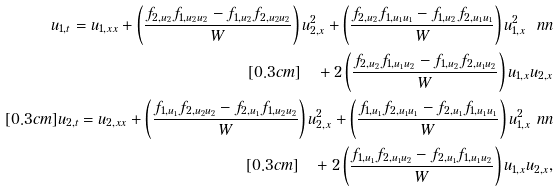Convert formula to latex. <formula><loc_0><loc_0><loc_500><loc_500>u _ { 1 , t } = u _ { 1 , x x } + \left ( \frac { f _ { 2 , u _ { 2 } } f _ { 1 , u _ { 2 } u _ { 2 } } - f _ { 1 , u _ { 2 } } f _ { 2 , u _ { 2 } u _ { 2 } } } { W } \right ) u _ { 2 , x } ^ { 2 } + \left ( \frac { f _ { 2 , u _ { 2 } } f _ { 1 , u _ { 1 } u _ { 1 } } - f _ { 1 , u _ { 2 } } f _ { 2 , u _ { 1 } u _ { 1 } } } { W } \right ) u _ { 1 , x } ^ { 2 } \ n n \\ [ 0 . 3 c m ] \quad + 2 \left ( \frac { f _ { 2 , u _ { 2 } } f _ { 1 , u _ { 1 } u _ { 2 } } - f _ { 1 , u _ { 2 } } f _ { 2 , u _ { 1 } u _ { 2 } } } { W } \right ) u _ { 1 , x } u _ { 2 , x } \\ [ 0 . 3 c m ] u _ { 2 , t } = u _ { 2 , x x } + \left ( \frac { f _ { 1 , u _ { 1 } } f _ { 2 , u _ { 2 } u _ { 2 } } - f _ { 2 , u _ { 1 } } f _ { 1 , u _ { 2 } u _ { 2 } } } { W } \right ) u _ { 2 , x } ^ { 2 } + \left ( \frac { f _ { 1 , u _ { 1 } } f _ { 2 , u _ { 1 } u _ { 1 } } - f _ { 2 , u _ { 1 } } f _ { 1 , u _ { 1 } u _ { 1 } } } { W } \right ) u _ { 1 , x } ^ { 2 } \ n n \\ [ 0 . 3 c m ] \quad + 2 \left ( \frac { f _ { 1 , u _ { 1 } } f _ { 2 , u _ { 1 } u _ { 2 } } - f _ { 2 , u _ { 1 } } f _ { 1 , u _ { 1 } u _ { 2 } } } { W } \right ) u _ { 1 , x } u _ { 2 , x } ,</formula> 